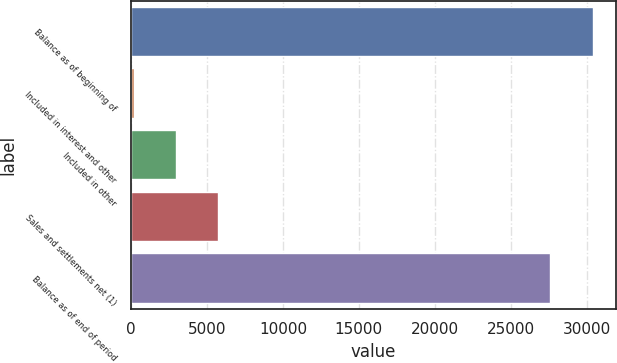Convert chart to OTSL. <chart><loc_0><loc_0><loc_500><loc_500><bar_chart><fcel>Balance as of beginning of<fcel>Included in interest and other<fcel>Included in other<fcel>Sales and settlements net (1)<fcel>Balance as of end of period<nl><fcel>30393.9<fcel>159<fcel>2942.9<fcel>5726.8<fcel>27610<nl></chart> 